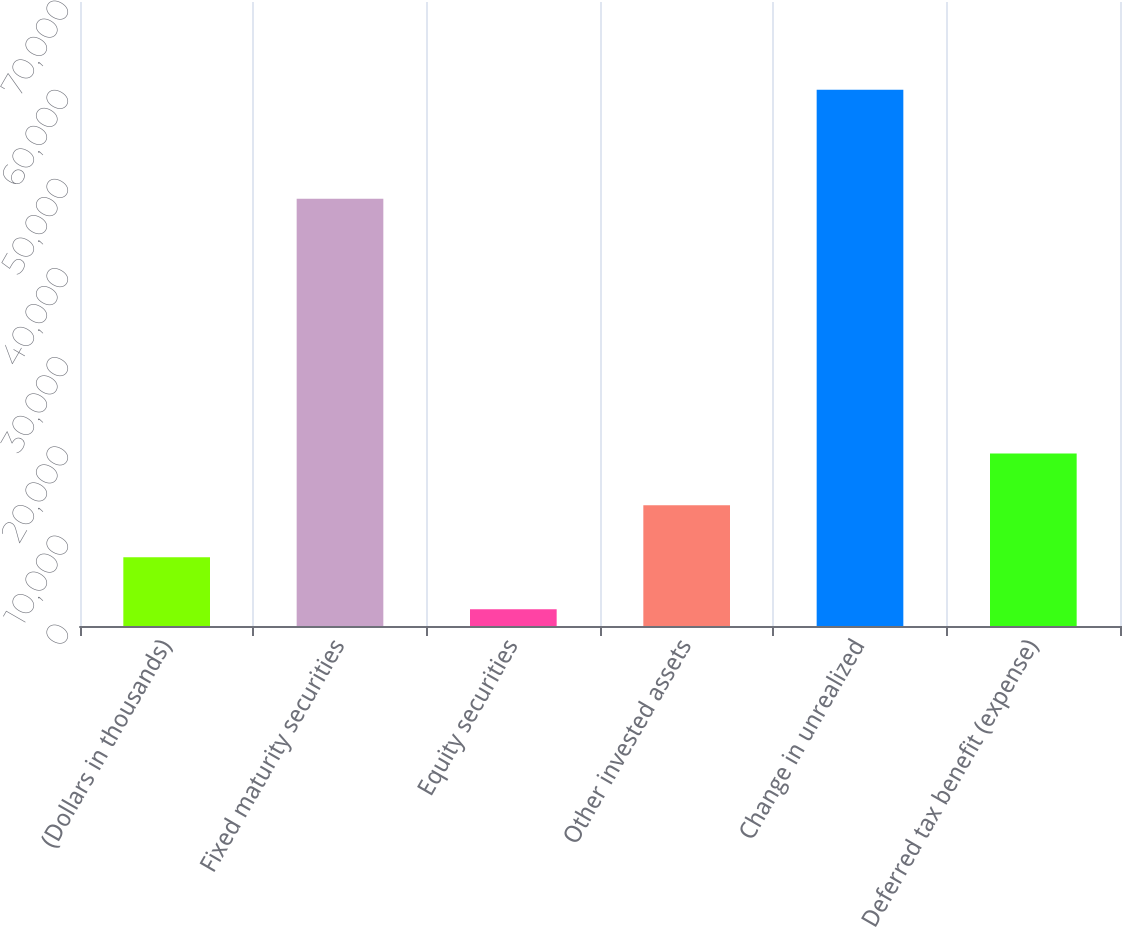Convert chart. <chart><loc_0><loc_0><loc_500><loc_500><bar_chart><fcel>(Dollars in thousands)<fcel>Fixed maturity securities<fcel>Equity securities<fcel>Other invested assets<fcel>Change in unrealized<fcel>Deferred tax benefit (expense)<nl><fcel>7706.6<fcel>47926<fcel>1878<fcel>13535.2<fcel>60164<fcel>19363.8<nl></chart> 